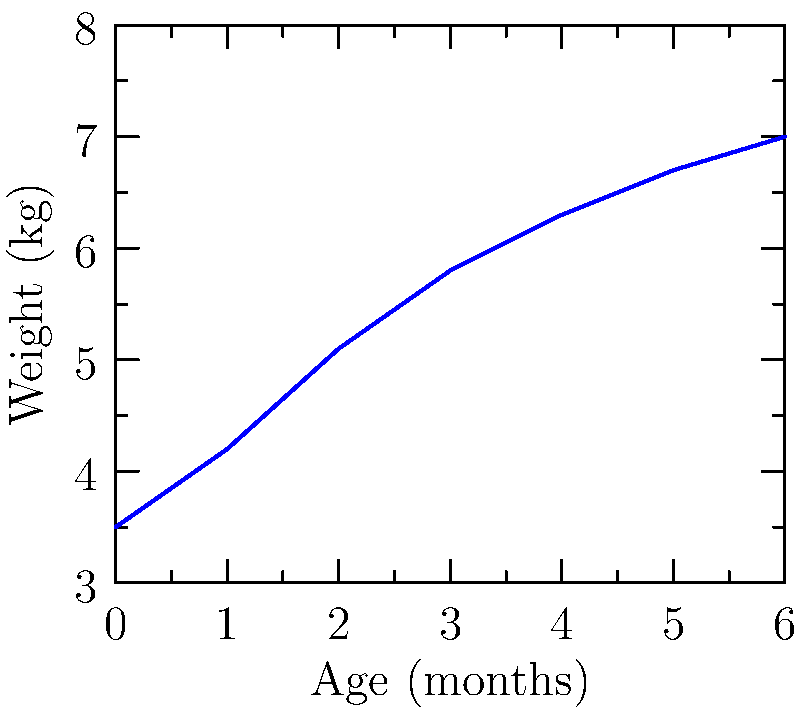Analyze the growth chart provided, which shows an infant's weight gain over the first 6 months of life. What is the approximate weight gain of the infant between 3 and 6 months of age? To determine the weight gain between 3 and 6 months, we need to:

1. Identify the weight at 3 months:
   From the graph, at 3 months, the weight is approximately 5.8 kg.

2. Identify the weight at 6 months:
   From the graph, at 6 months, the weight is 7.0 kg.

3. Calculate the difference:
   Weight gain = Weight at 6 months - Weight at 3 months
   $$ \text{Weight gain} = 7.0 \text{ kg} - 5.8 \text{ kg} = 1.2 \text{ kg} $$

Therefore, the approximate weight gain of the infant between 3 and 6 months of age is 1.2 kg.
Answer: 1.2 kg 